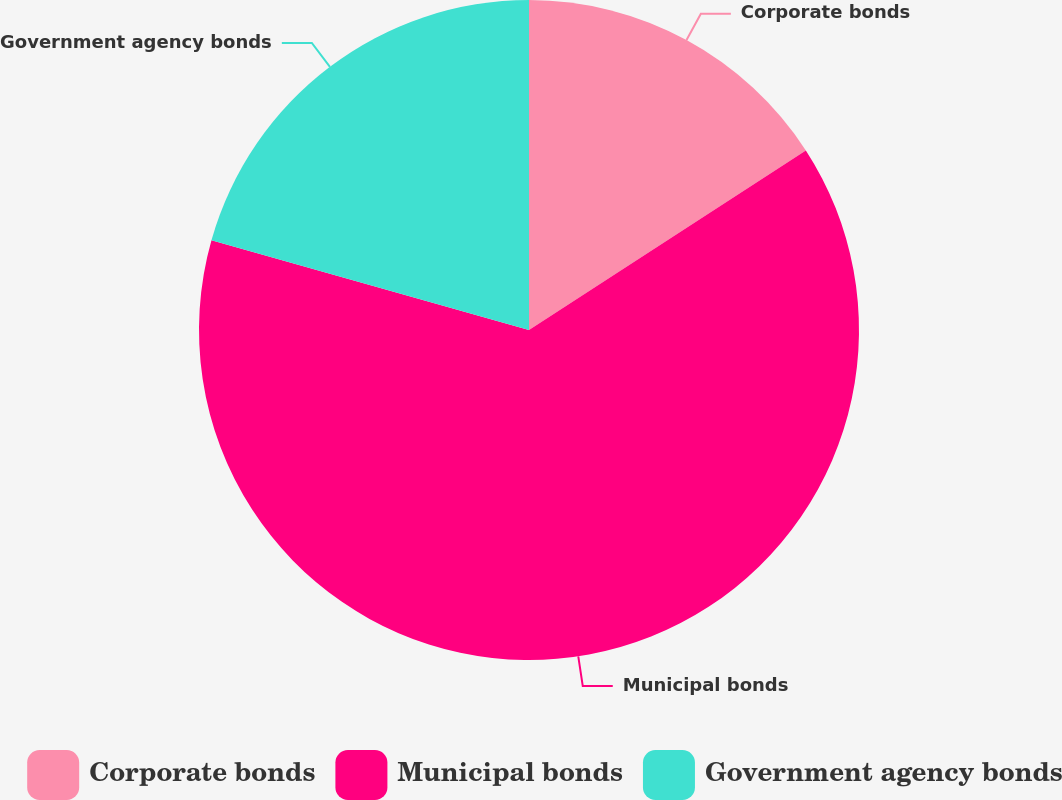<chart> <loc_0><loc_0><loc_500><loc_500><pie_chart><fcel>Corporate bonds<fcel>Municipal bonds<fcel>Government agency bonds<nl><fcel>15.84%<fcel>63.54%<fcel>20.61%<nl></chart> 